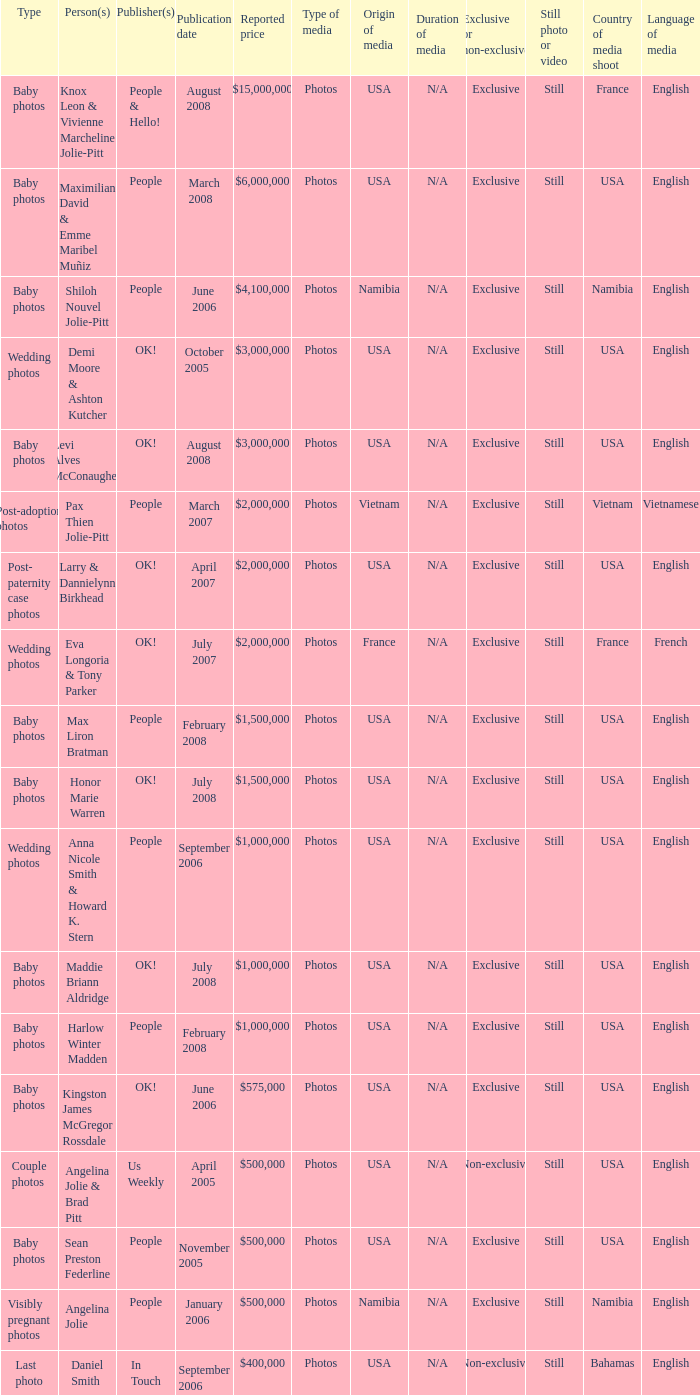What was the publication date of the photos of Sean Preston Federline that cost $500,000 and were published by People? November 2005. 